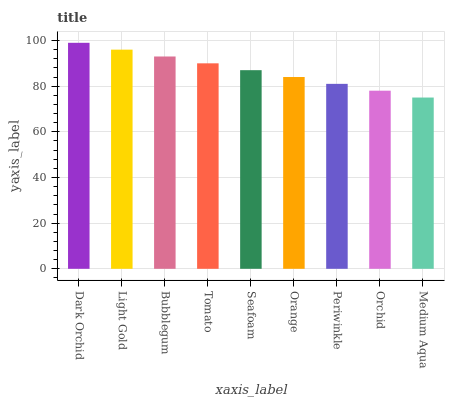Is Medium Aqua the minimum?
Answer yes or no. Yes. Is Dark Orchid the maximum?
Answer yes or no. Yes. Is Light Gold the minimum?
Answer yes or no. No. Is Light Gold the maximum?
Answer yes or no. No. Is Dark Orchid greater than Light Gold?
Answer yes or no. Yes. Is Light Gold less than Dark Orchid?
Answer yes or no. Yes. Is Light Gold greater than Dark Orchid?
Answer yes or no. No. Is Dark Orchid less than Light Gold?
Answer yes or no. No. Is Seafoam the high median?
Answer yes or no. Yes. Is Seafoam the low median?
Answer yes or no. Yes. Is Periwinkle the high median?
Answer yes or no. No. Is Tomato the low median?
Answer yes or no. No. 